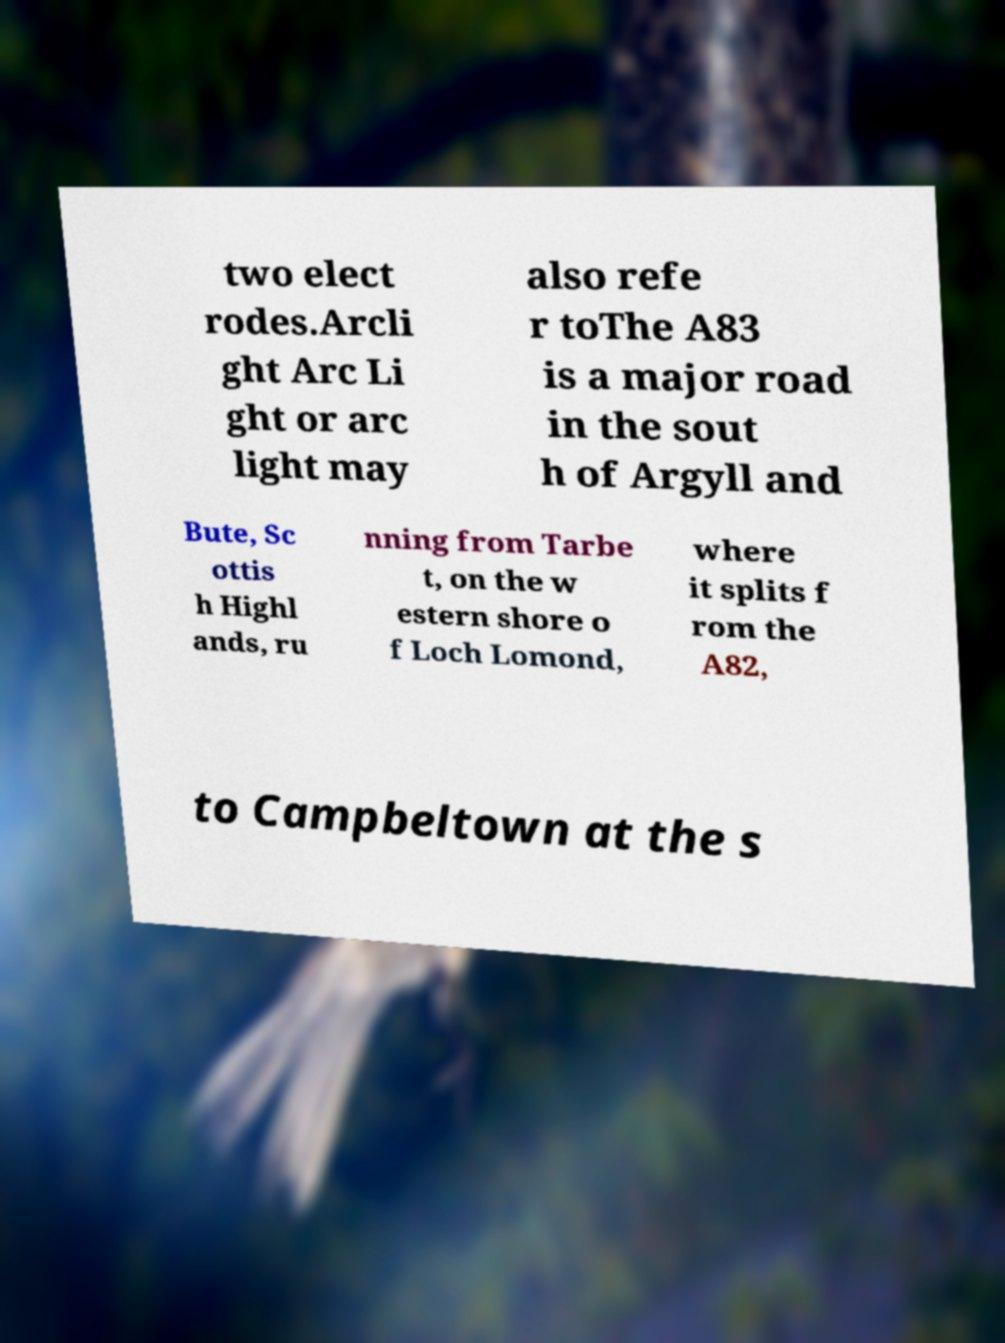Can you read and provide the text displayed in the image?This photo seems to have some interesting text. Can you extract and type it out for me? two elect rodes.Arcli ght Arc Li ght or arc light may also refe r toThe A83 is a major road in the sout h of Argyll and Bute, Sc ottis h Highl ands, ru nning from Tarbe t, on the w estern shore o f Loch Lomond, where it splits f rom the A82, to Campbeltown at the s 